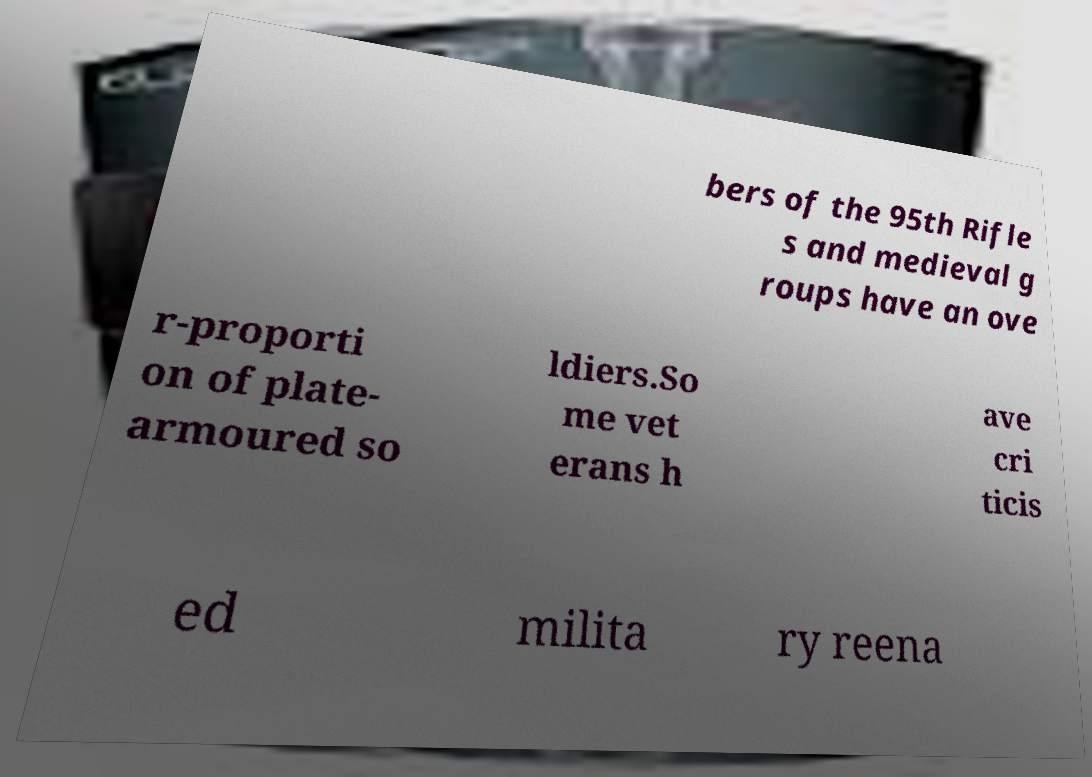Could you extract and type out the text from this image? bers of the 95th Rifle s and medieval g roups have an ove r-proporti on of plate- armoured so ldiers.So me vet erans h ave cri ticis ed milita ry reena 